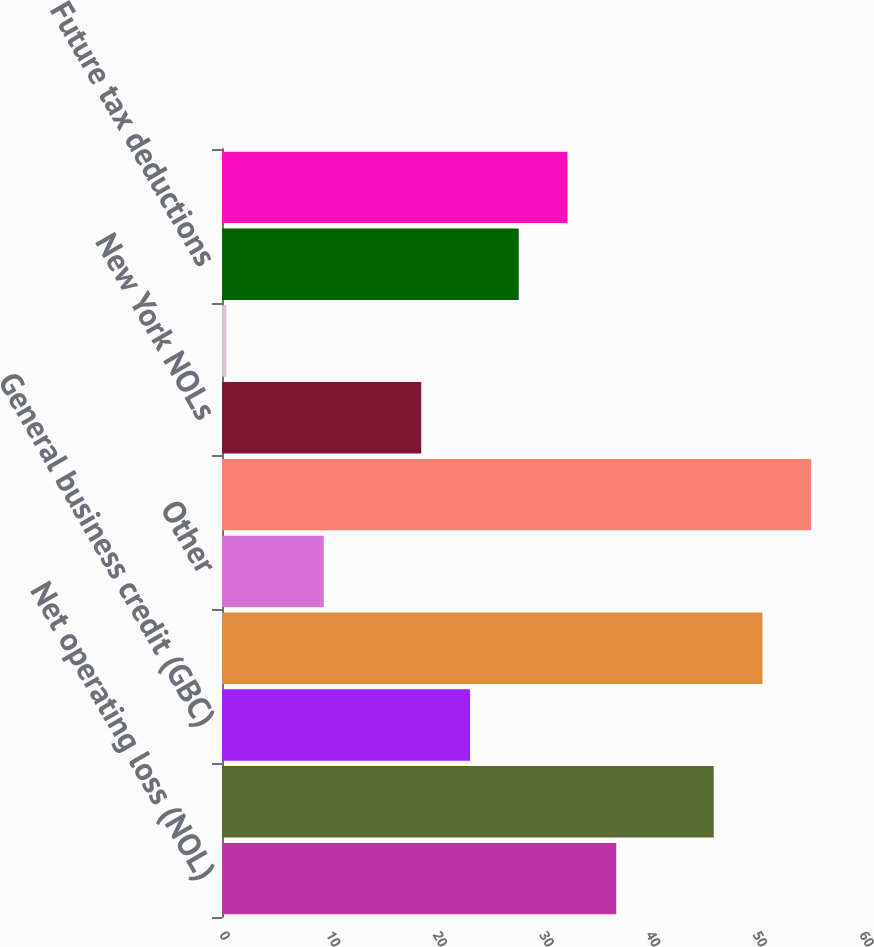Convert chart to OTSL. <chart><loc_0><loc_0><loc_500><loc_500><bar_chart><fcel>Net operating loss (NOL)<fcel>Foreign tax credit (FTC)<fcel>General business credit (GBC)<fcel>Future tax deductions and<fcel>Other<fcel>Total US federal<fcel>New York NOLs<fcel>Other state NOLs<fcel>Future tax deductions<fcel>Total state and local<nl><fcel>36.96<fcel>46.1<fcel>23.25<fcel>50.67<fcel>9.54<fcel>55.24<fcel>18.68<fcel>0.4<fcel>27.82<fcel>32.39<nl></chart> 